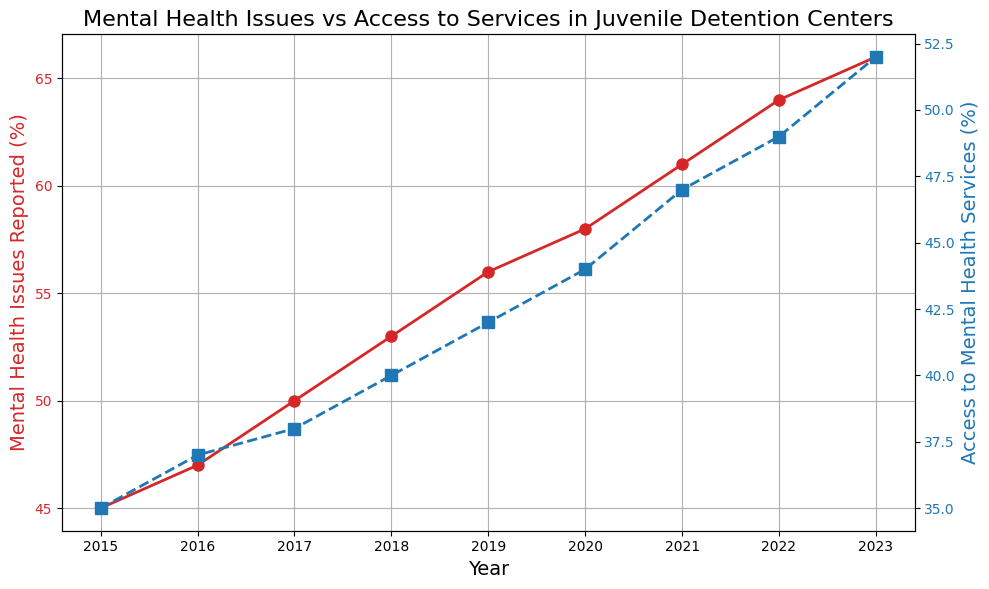What is the overall trend in the percentage of mental health issues reported by incarcerated juveniles from 2015 to 2023? The line representing the percentage of mental health issues reported by incarcerated juveniles shows an upward trend from 2015 to 2023. The values increase from 45% in 2015 to 66% in 2023.
Answer: Upward trend By how much did the access to mental health services increase from 2015 to 2023? The access to mental health services percentage in 2015 is 35%, and it rises to 52% in 2023. The increase is calculated as 52% - 35% = 17%.
Answer: 17% In which year was the gap between reported mental health issues and access to mental health services the smallest, and what was the value of this gap? By examining the plot, the smallest visual gap appears in 2023. The reported mental health issues were 66%, and the access to services was 52%. The gap is 66% - 52% = 14%.
Answer: 2023, 14% Compare the rate of increase in reported mental health issues and access to services from 2015 to 2023. Which one increased more rapidly? To compare rates, we can consider the start and end values. Mental health issues increased from 45% to 66% (a 21% increase), while access to services increased from 35% to 52% (a 17% increase). Therefore, mental health issues increased more rapidly.
Answer: Mental health issues What was the percentage difference between reported mental health issues and access to services in 2020? In 2020, the reported mental health issues are 58%, and access to services is 44%. The difference is 58% - 44% = 14%.
Answer: 14% Did the percentage of access to mental health services ever exceed 50% from 2015 to 2023? By following the plot line for access to mental health services (in blue), it only exceeds the 50% mark in 2023, where it reaches 52%.
Answer: Yes, in 2023 What is the average annual percentage increase in reported mental health issues between 2015 and 2023? The total increase is from 45% to 66%, which is 21% over 8 years. The average annual increase is 21% / 8 ≈ 2.625% per year.
Answer: 2.625% Compare the trend lines of reported mental health issues and access to services. Are they always moving in the same direction annually? Upon reviewing both line plots together, we observe that in every year, when the mental health issues percentage increases, the access to services percentage also increases. Thus, they always move in the same direction.
Answer: Yes What was the highest percentage of reported mental health issues over this period, and in which year did it occur? The highest value in the plot for mental health issues reported is 66%, which occurs in 2023.
Answer: 66%, 2023 